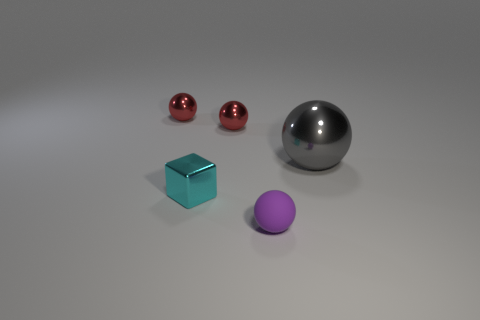There is a tiny object that is right of the metallic block and on the left side of the small purple ball; what is its color?
Offer a terse response. Red. The gray shiny ball is what size?
Keep it short and to the point. Large. How many matte things are the same size as the cyan metallic block?
Give a very brief answer. 1. Are the sphere on the right side of the purple sphere and the object that is on the left side of the cyan object made of the same material?
Provide a succinct answer. Yes. What is the material of the small sphere in front of the small red thing right of the tiny cyan metal thing?
Keep it short and to the point. Rubber. What is the thing that is right of the tiny purple object made of?
Your answer should be compact. Metal. How many red objects have the same shape as the big gray thing?
Give a very brief answer. 2. What is the material of the sphere that is in front of the shiny object on the right side of the tiny purple rubber sphere that is in front of the cube?
Offer a very short reply. Rubber. Are there any tiny red spheres behind the tiny cyan object?
Offer a terse response. Yes. What is the shape of the other cyan object that is the same size as the matte thing?
Offer a terse response. Cube. 